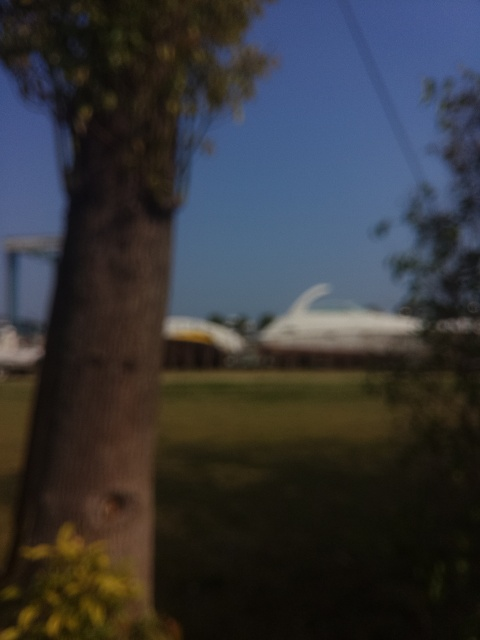Why does the image have a hazy beauty?
A. Enhanced saturation
B. Overexposure
C. Blurry appearance resembling a painting
D. High contrast and clarity The image has a hazy beauty primarily due to its blurry appearance, which gives it a dreamlike quality reminiscent of a painting. The lack of sharpness in the image softens the details and creates a gentle aesthetic that might not be intentional but ends up giving the scene an ethereal charm. 